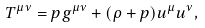Convert formula to latex. <formula><loc_0><loc_0><loc_500><loc_500>T ^ { \mu \nu } = p g ^ { \mu \nu } + ( \rho + p ) u ^ { \mu } u ^ { \nu } ,</formula> 